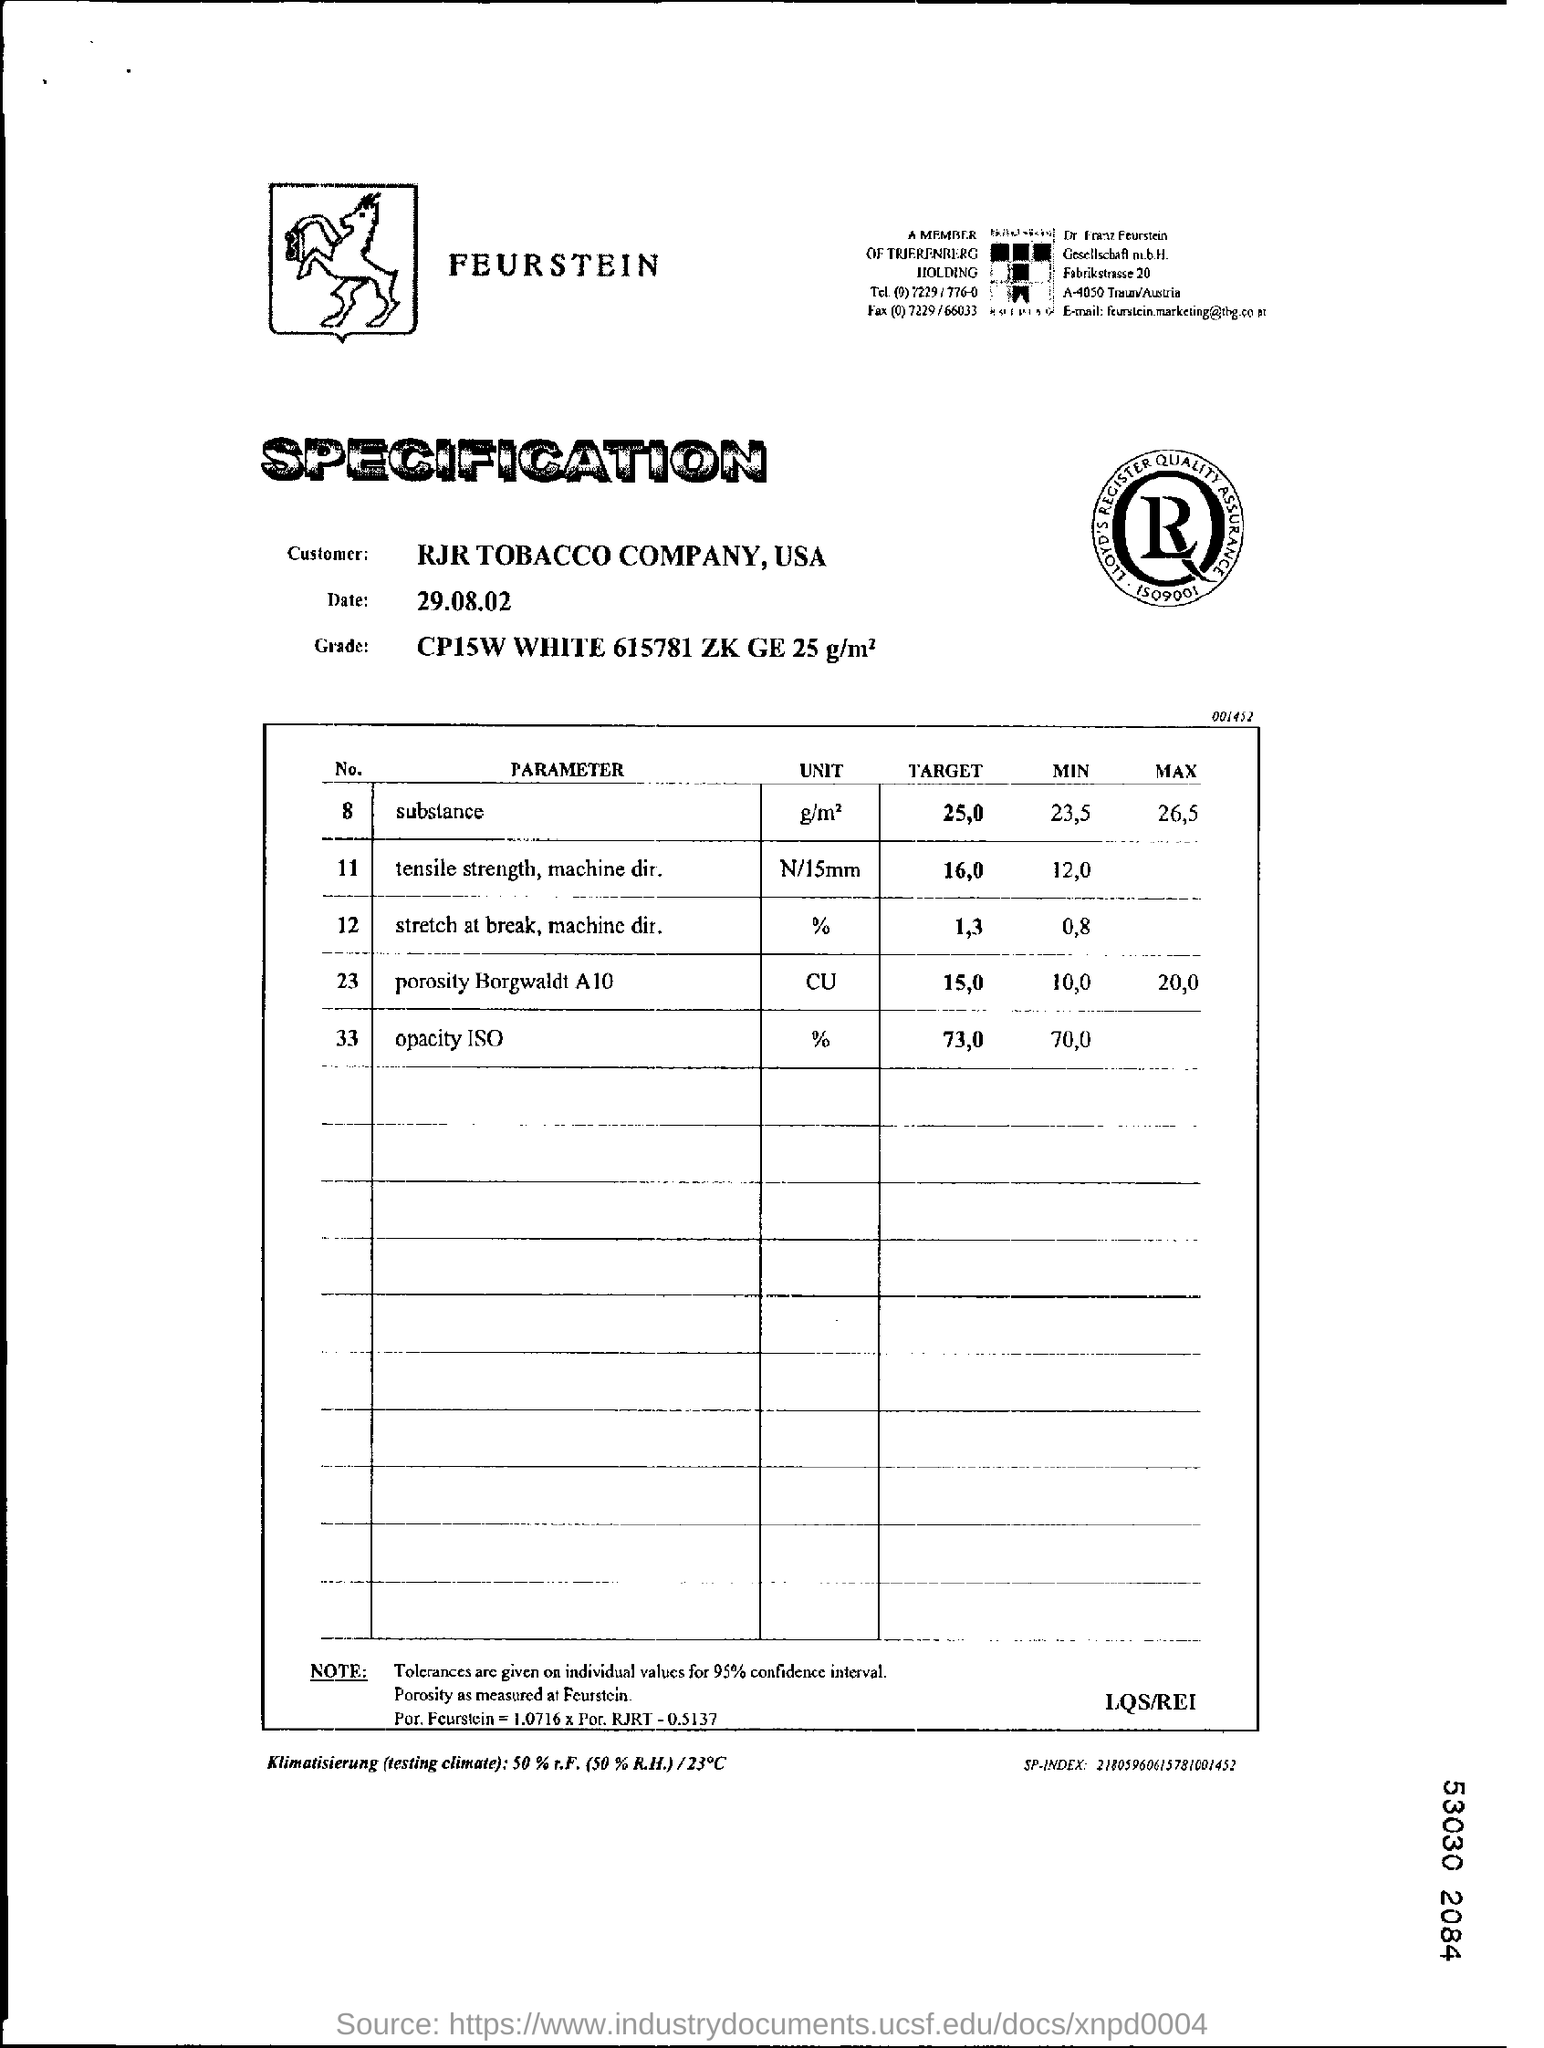Identify some key points in this picture. I, being a customer, am inquiring about the name of the company I am dealing with, and it is RJR TOBACCO COMPANY. 